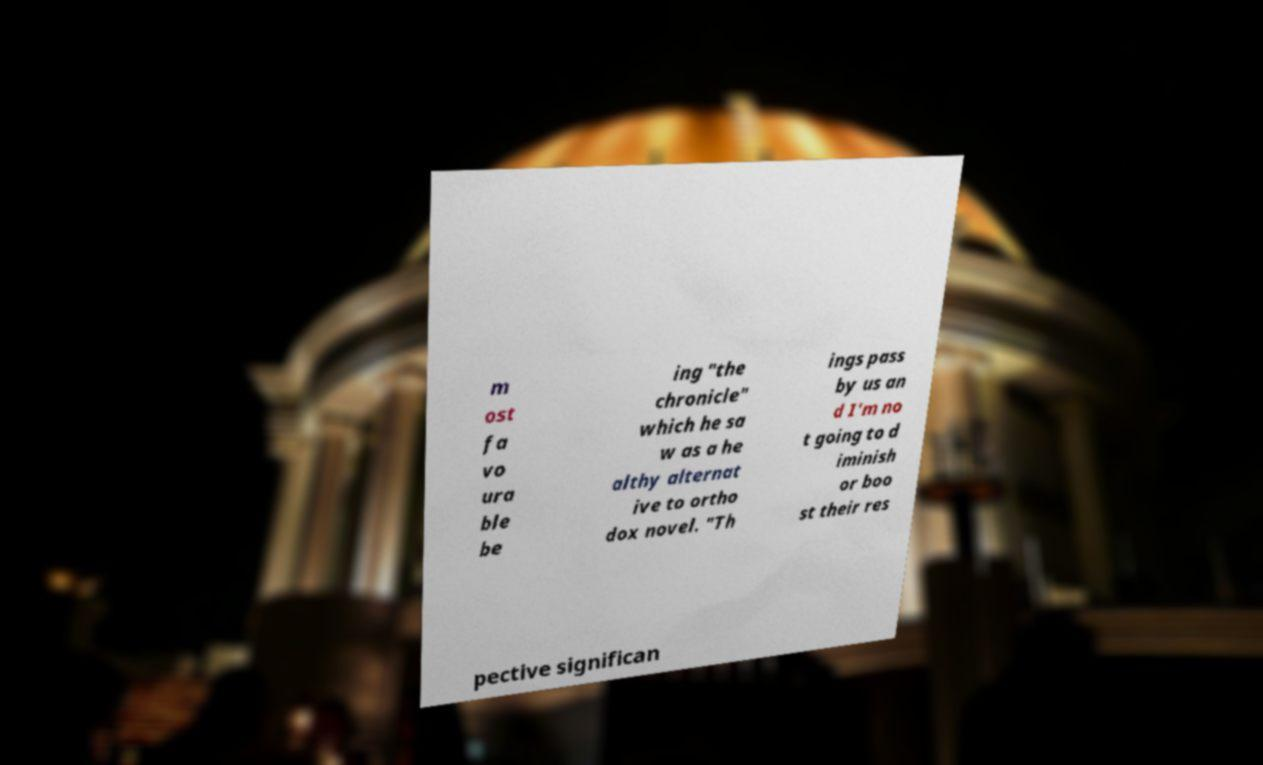Can you read and provide the text displayed in the image?This photo seems to have some interesting text. Can you extract and type it out for me? m ost fa vo ura ble be ing "the chronicle" which he sa w as a he althy alternat ive to ortho dox novel. "Th ings pass by us an d I'm no t going to d iminish or boo st their res pective significan 